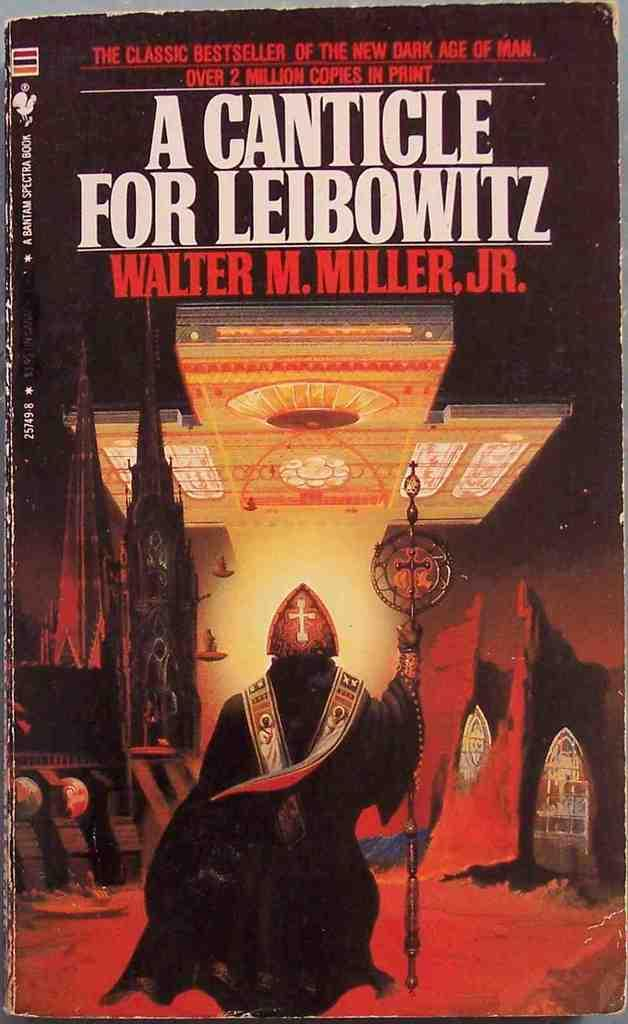Provide a one-sentence caption for the provided image. The front cover of Walter M. Miller jr's A Canticle for Leibowitz shows a robed and masked figure holding a scepter. 